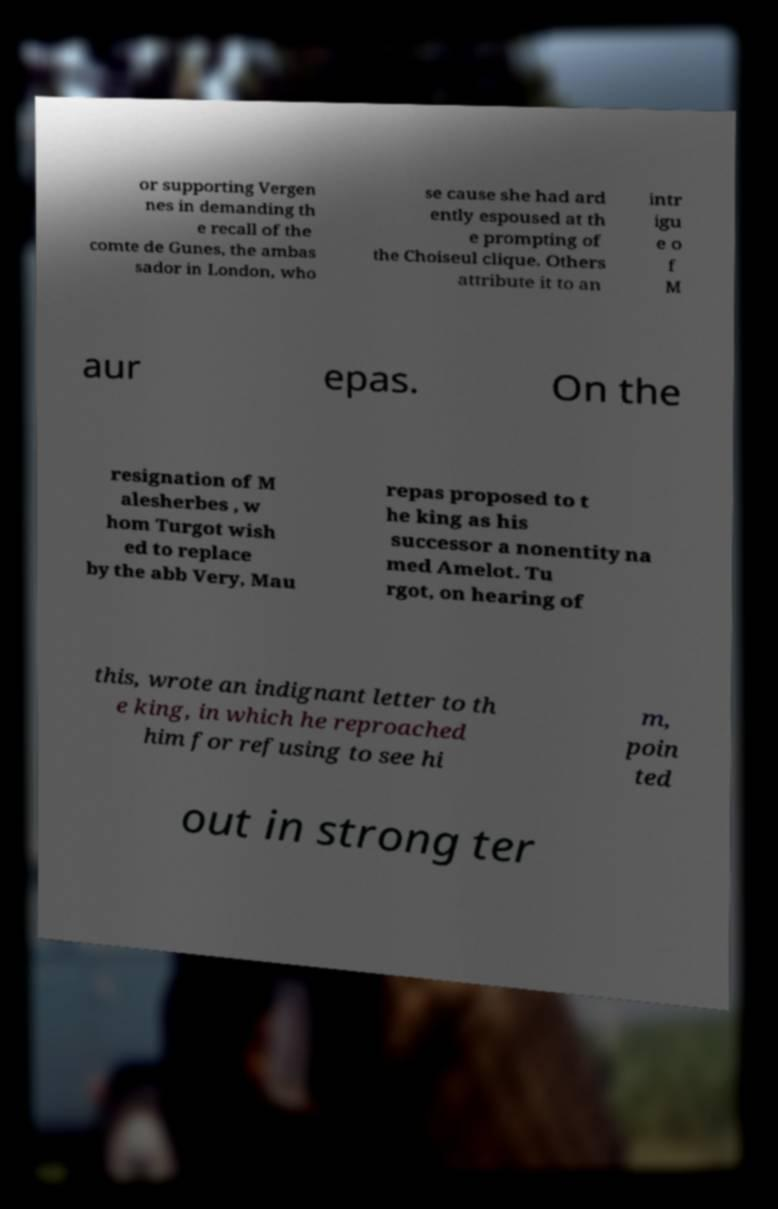There's text embedded in this image that I need extracted. Can you transcribe it verbatim? or supporting Vergen nes in demanding th e recall of the comte de Gunes, the ambas sador in London, who se cause she had ard ently espoused at th e prompting of the Choiseul clique. Others attribute it to an intr igu e o f M aur epas. On the resignation of M alesherbes , w hom Turgot wish ed to replace by the abb Very, Mau repas proposed to t he king as his successor a nonentity na med Amelot. Tu rgot, on hearing of this, wrote an indignant letter to th e king, in which he reproached him for refusing to see hi m, poin ted out in strong ter 